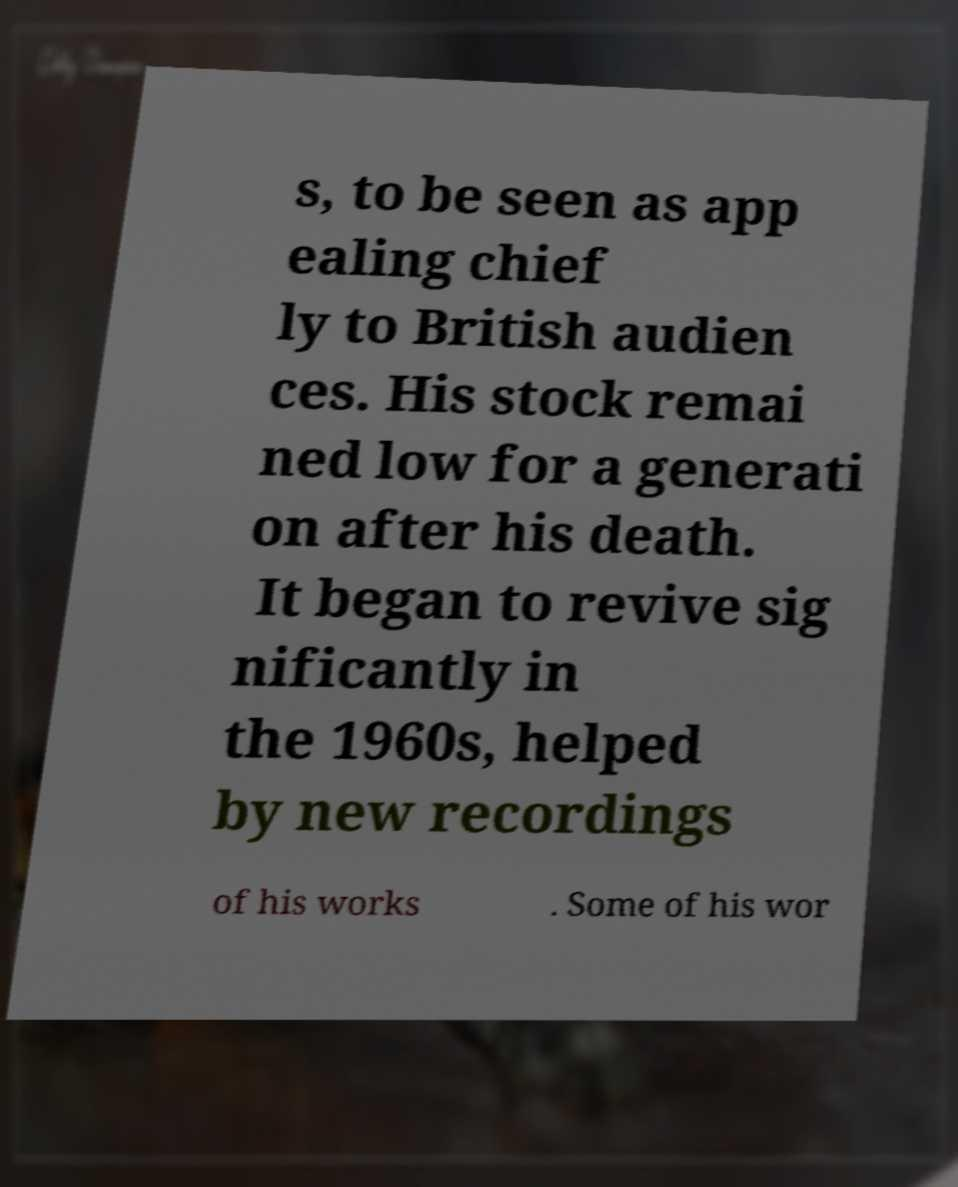Please identify and transcribe the text found in this image. s, to be seen as app ealing chief ly to British audien ces. His stock remai ned low for a generati on after his death. It began to revive sig nificantly in the 1960s, helped by new recordings of his works . Some of his wor 